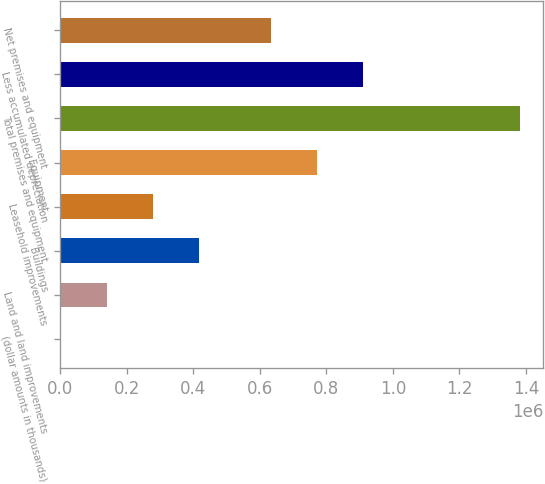Convert chart to OTSL. <chart><loc_0><loc_0><loc_500><loc_500><bar_chart><fcel>(dollar amounts in thousands)<fcel>Land and land improvements<fcel>Buildings<fcel>Leasehold improvements<fcel>Equipment<fcel>Total premises and equipment<fcel>Less accumulated depreciation<fcel>Net premises and equipment<nl><fcel>2013<fcel>140146<fcel>416412<fcel>278279<fcel>772790<fcel>1.38334e+06<fcel>910923<fcel>634657<nl></chart> 